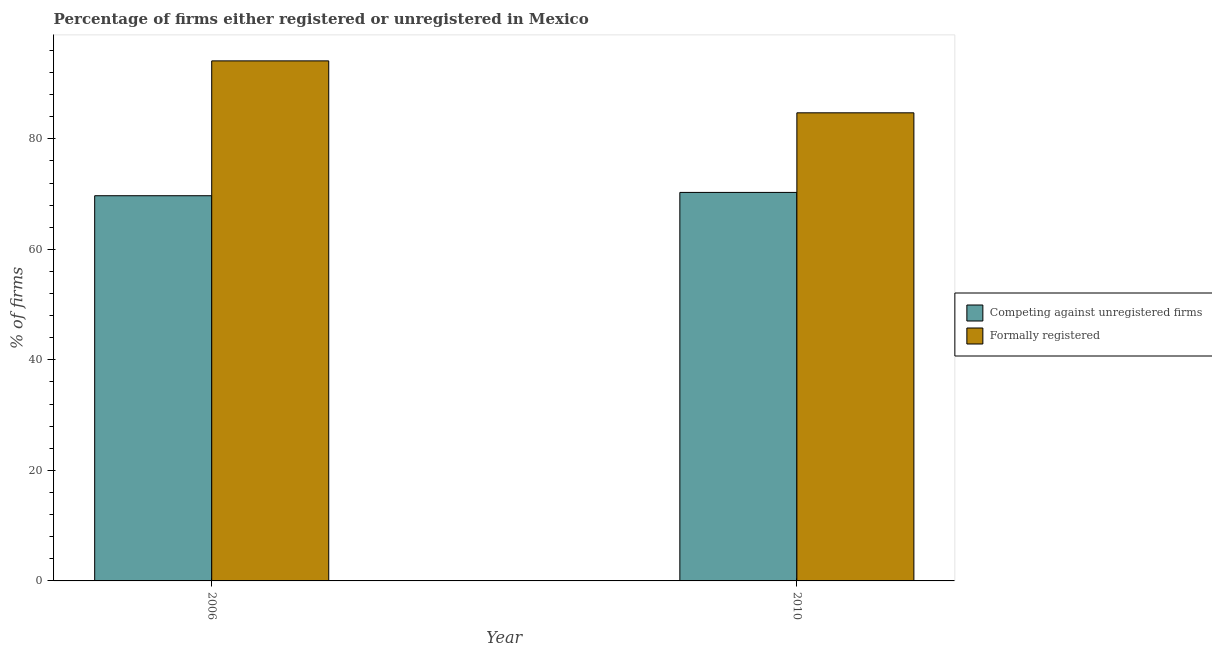How many different coloured bars are there?
Offer a terse response. 2. How many groups of bars are there?
Offer a very short reply. 2. Are the number of bars on each tick of the X-axis equal?
Give a very brief answer. Yes. How many bars are there on the 1st tick from the right?
Make the answer very short. 2. In how many cases, is the number of bars for a given year not equal to the number of legend labels?
Offer a terse response. 0. What is the percentage of registered firms in 2010?
Your answer should be very brief. 70.3. Across all years, what is the maximum percentage of registered firms?
Offer a very short reply. 70.3. Across all years, what is the minimum percentage of registered firms?
Your answer should be compact. 69.7. What is the total percentage of registered firms in the graph?
Your response must be concise. 140. What is the difference between the percentage of registered firms in 2006 and that in 2010?
Your answer should be compact. -0.6. What is the difference between the percentage of registered firms in 2010 and the percentage of formally registered firms in 2006?
Offer a very short reply. 0.6. In how many years, is the percentage of registered firms greater than 84 %?
Ensure brevity in your answer.  0. What is the ratio of the percentage of registered firms in 2006 to that in 2010?
Your answer should be very brief. 0.99. In how many years, is the percentage of registered firms greater than the average percentage of registered firms taken over all years?
Provide a succinct answer. 1. What does the 1st bar from the left in 2010 represents?
Your response must be concise. Competing against unregistered firms. What does the 1st bar from the right in 2010 represents?
Provide a short and direct response. Formally registered. How many bars are there?
Your answer should be very brief. 4. Does the graph contain grids?
Your response must be concise. No. How many legend labels are there?
Provide a short and direct response. 2. How are the legend labels stacked?
Your answer should be compact. Vertical. What is the title of the graph?
Make the answer very short. Percentage of firms either registered or unregistered in Mexico. Does "Exports of goods" appear as one of the legend labels in the graph?
Provide a succinct answer. No. What is the label or title of the Y-axis?
Ensure brevity in your answer.  % of firms. What is the % of firms of Competing against unregistered firms in 2006?
Provide a short and direct response. 69.7. What is the % of firms of Formally registered in 2006?
Your answer should be very brief. 94.1. What is the % of firms of Competing against unregistered firms in 2010?
Ensure brevity in your answer.  70.3. What is the % of firms of Formally registered in 2010?
Your answer should be very brief. 84.7. Across all years, what is the maximum % of firms in Competing against unregistered firms?
Make the answer very short. 70.3. Across all years, what is the maximum % of firms in Formally registered?
Offer a terse response. 94.1. Across all years, what is the minimum % of firms of Competing against unregistered firms?
Your answer should be very brief. 69.7. Across all years, what is the minimum % of firms of Formally registered?
Your answer should be compact. 84.7. What is the total % of firms in Competing against unregistered firms in the graph?
Make the answer very short. 140. What is the total % of firms in Formally registered in the graph?
Make the answer very short. 178.8. What is the difference between the % of firms in Competing against unregistered firms in 2006 and that in 2010?
Provide a short and direct response. -0.6. What is the difference between the % of firms of Formally registered in 2006 and that in 2010?
Offer a terse response. 9.4. What is the difference between the % of firms of Competing against unregistered firms in 2006 and the % of firms of Formally registered in 2010?
Keep it short and to the point. -15. What is the average % of firms in Formally registered per year?
Your answer should be compact. 89.4. In the year 2006, what is the difference between the % of firms in Competing against unregistered firms and % of firms in Formally registered?
Offer a very short reply. -24.4. In the year 2010, what is the difference between the % of firms of Competing against unregistered firms and % of firms of Formally registered?
Your answer should be compact. -14.4. What is the ratio of the % of firms in Formally registered in 2006 to that in 2010?
Offer a very short reply. 1.11. What is the difference between the highest and the second highest % of firms in Competing against unregistered firms?
Your response must be concise. 0.6. What is the difference between the highest and the second highest % of firms in Formally registered?
Your answer should be very brief. 9.4. What is the difference between the highest and the lowest % of firms of Formally registered?
Your answer should be compact. 9.4. 